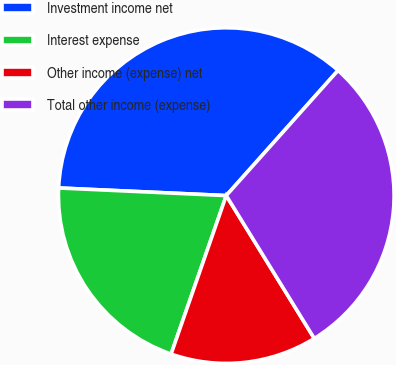Convert chart to OTSL. <chart><loc_0><loc_0><loc_500><loc_500><pie_chart><fcel>Investment income net<fcel>Interest expense<fcel>Other income (expense) net<fcel>Total other income (expense)<nl><fcel>35.88%<fcel>20.39%<fcel>14.12%<fcel>29.61%<nl></chart> 